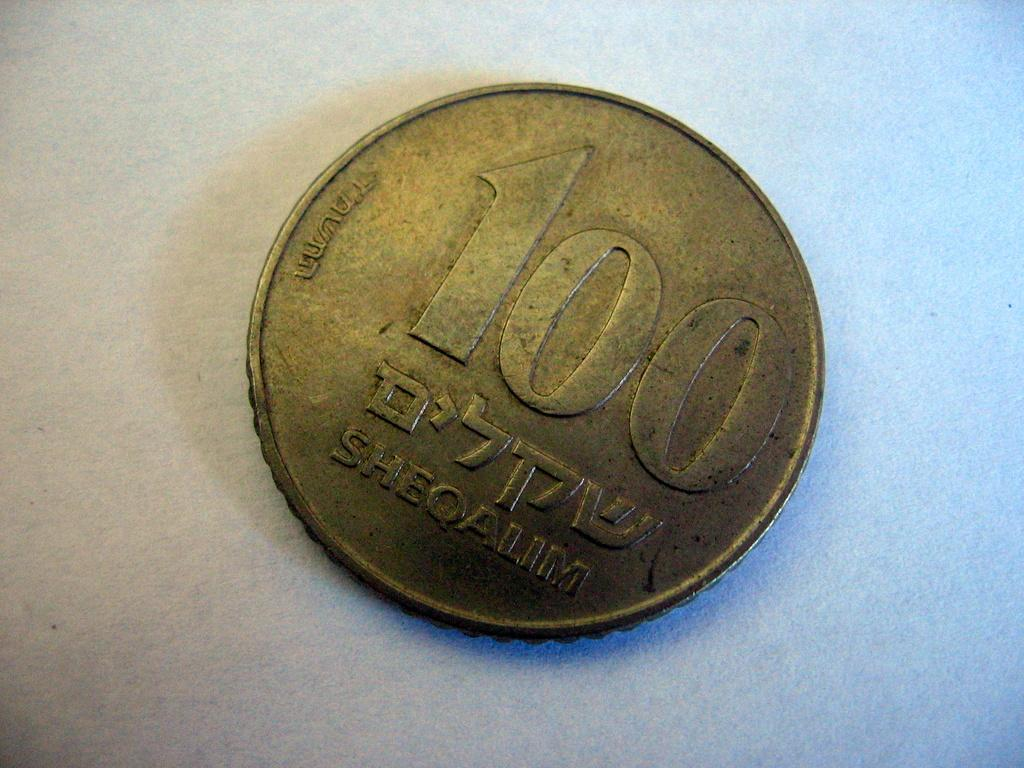<image>
Summarize the visual content of the image. 100 Sheqalim is etched onto the backside of this coin. 